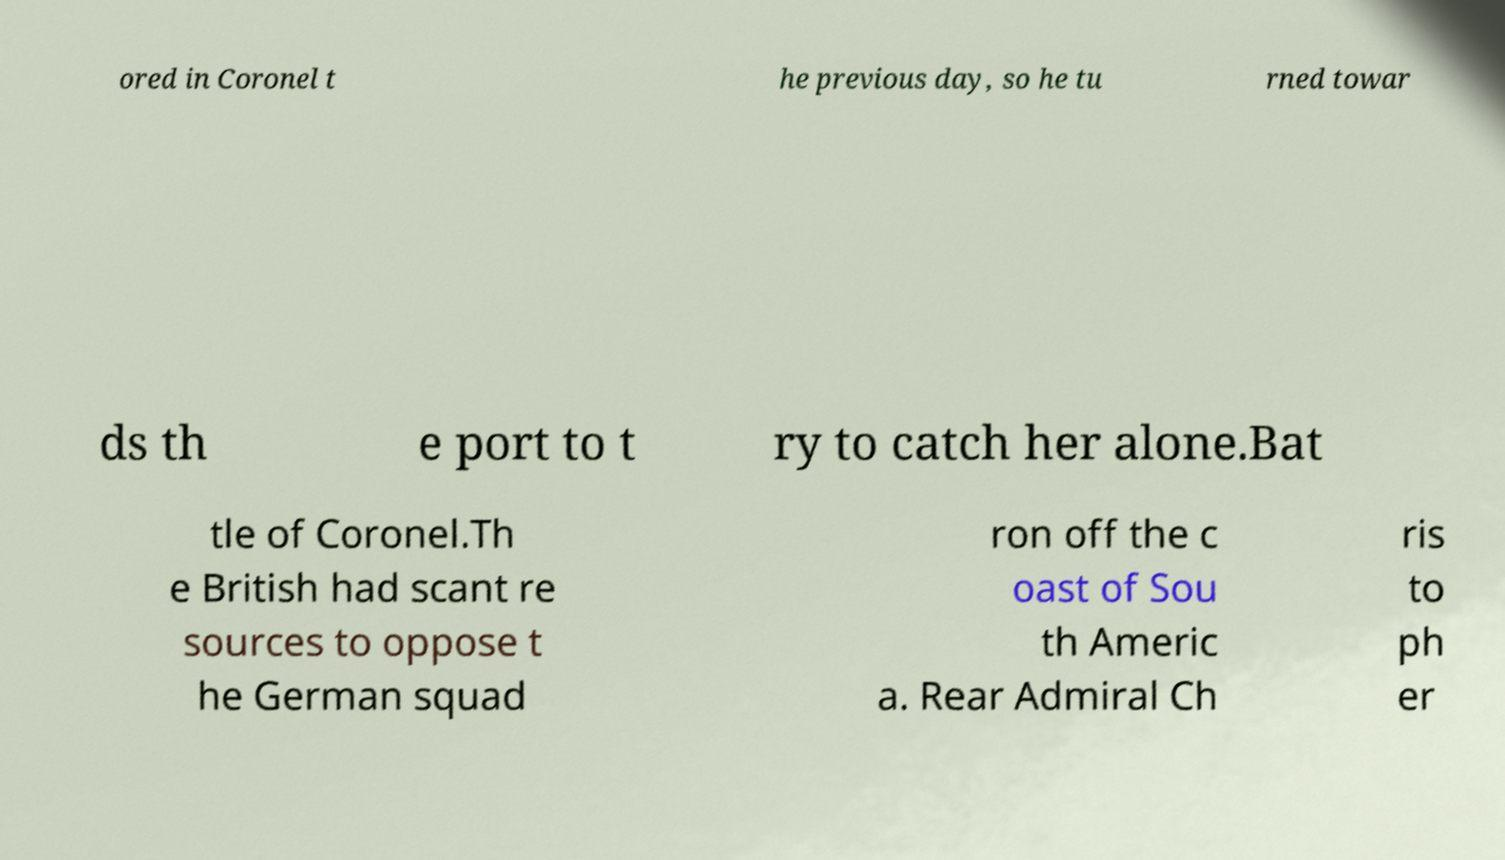For documentation purposes, I need the text within this image transcribed. Could you provide that? ored in Coronel t he previous day, so he tu rned towar ds th e port to t ry to catch her alone.Bat tle of Coronel.Th e British had scant re sources to oppose t he German squad ron off the c oast of Sou th Americ a. Rear Admiral Ch ris to ph er 